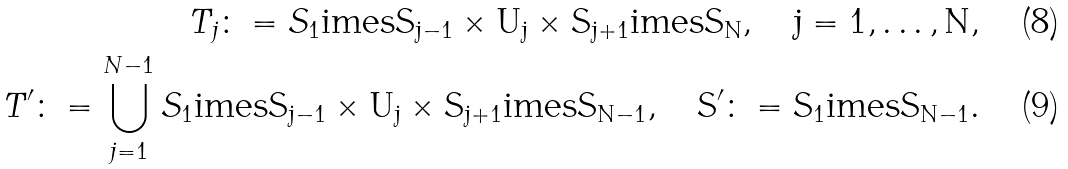<formula> <loc_0><loc_0><loc_500><loc_500>T _ { j } \colon = S _ { 1 } \tt i m e s S _ { j - 1 } \times U _ { j } \times S _ { j + 1 } \tt i m e s S _ { N } , \quad j = 1 , \dots , N , \\ T ^ { \prime } \colon = \bigcup _ { j = 1 } ^ { N - 1 } S _ { 1 } \tt i m e s S _ { j - 1 } \times U _ { j } \times S _ { j + 1 } \tt i m e s S _ { N - 1 } , \quad S ^ { \prime } \colon = S _ { 1 } \tt i m e s S _ { N - 1 } .</formula> 